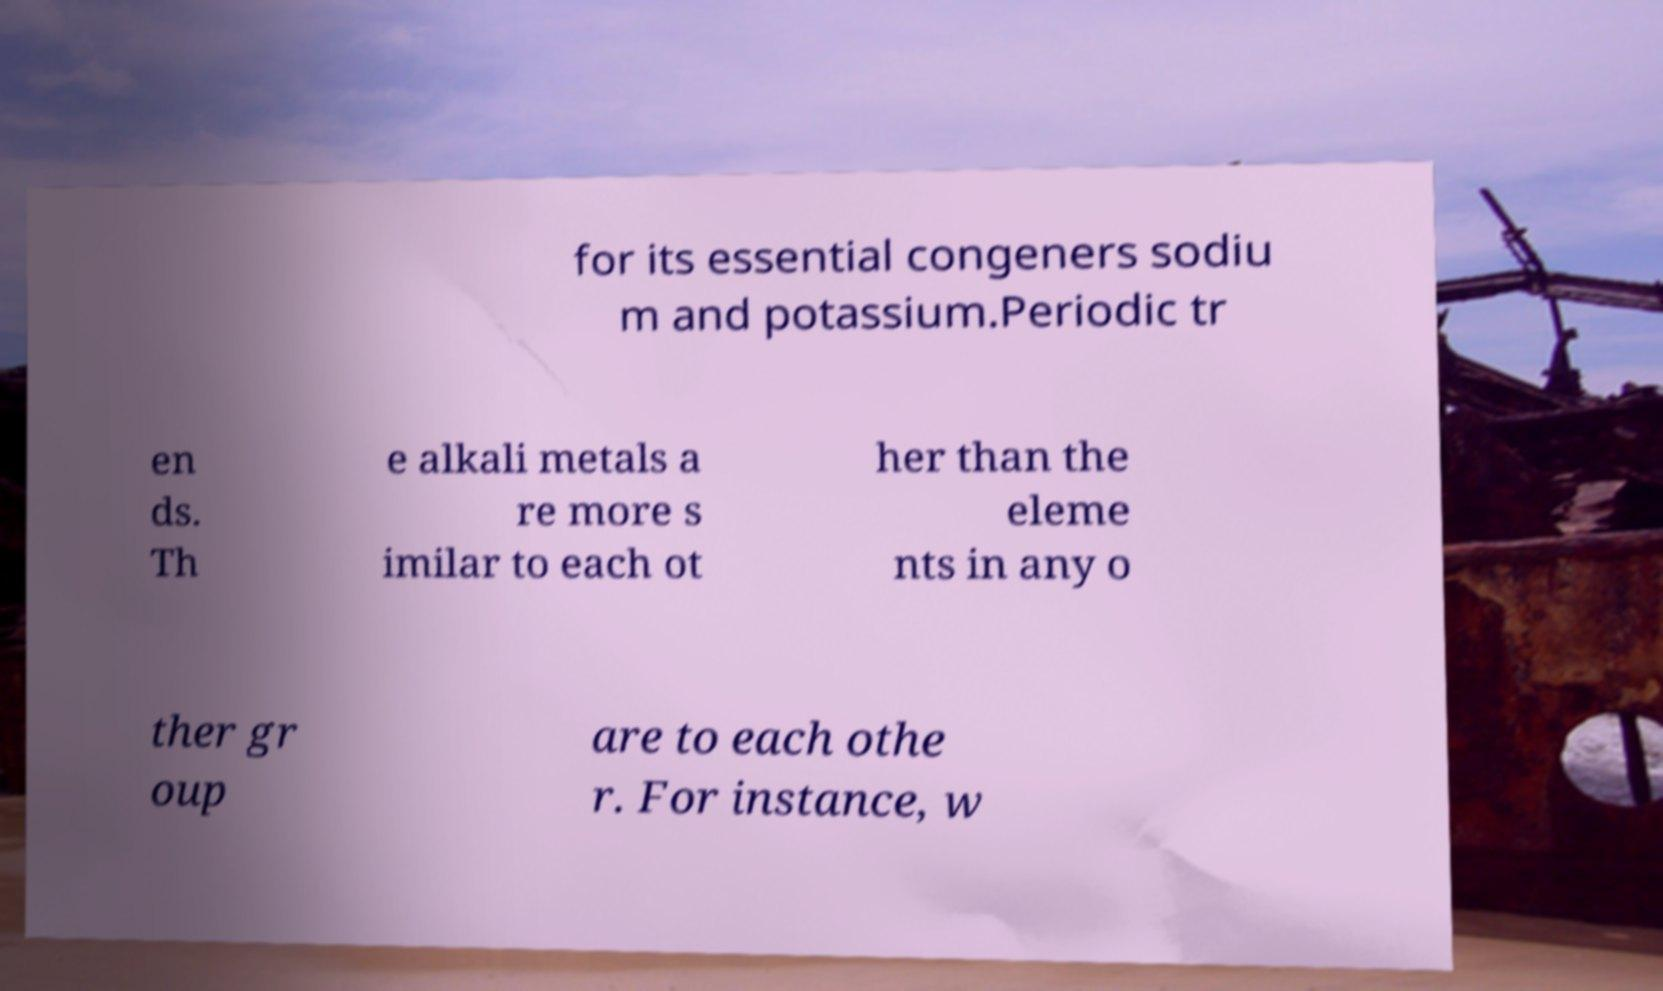There's text embedded in this image that I need extracted. Can you transcribe it verbatim? for its essential congeners sodiu m and potassium.Periodic tr en ds. Th e alkali metals a re more s imilar to each ot her than the eleme nts in any o ther gr oup are to each othe r. For instance, w 